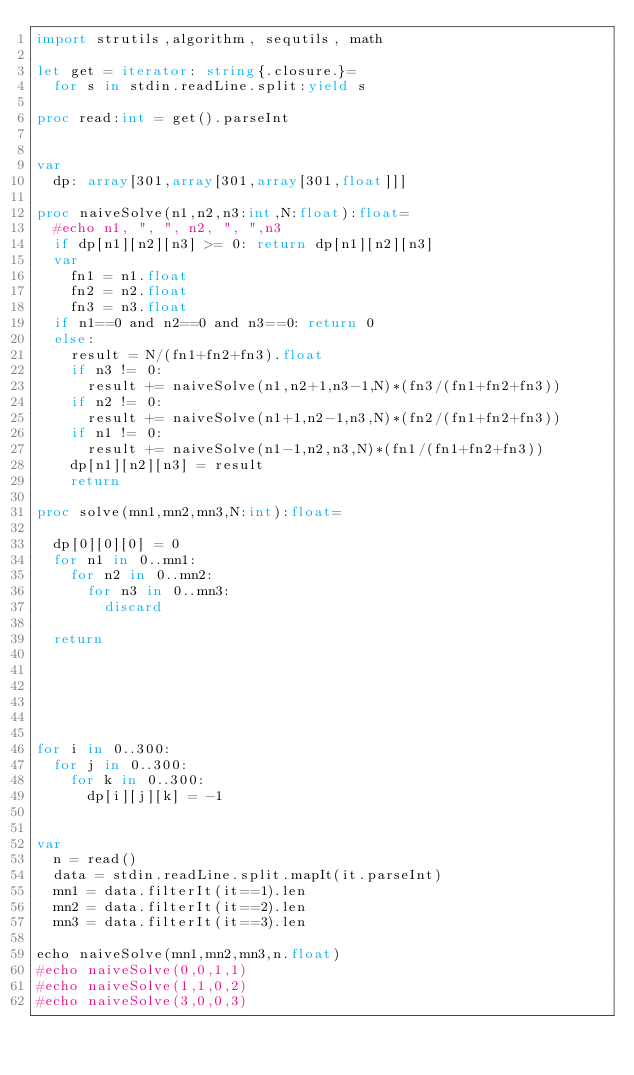<code> <loc_0><loc_0><loc_500><loc_500><_Nim_>import strutils,algorithm, sequtils, math

let get = iterator: string{.closure.}=
  for s in stdin.readLine.split:yield s

proc read:int = get().parseInt


var
  dp: array[301,array[301,array[301,float]]]

proc naiveSolve(n1,n2,n3:int,N:float):float=
  #echo n1, ", ", n2, ", ",n3
  if dp[n1][n2][n3] >= 0: return dp[n1][n2][n3]
  var
    fn1 = n1.float
    fn2 = n2.float
    fn3 = n3.float
  if n1==0 and n2==0 and n3==0: return 0
  else:
    result = N/(fn1+fn2+fn3).float
    if n3 != 0:
      result += naiveSolve(n1,n2+1,n3-1,N)*(fn3/(fn1+fn2+fn3))
    if n2 != 0:
      result += naiveSolve(n1+1,n2-1,n3,N)*(fn2/(fn1+fn2+fn3))
    if n1 != 0:
      result += naiveSolve(n1-1,n2,n3,N)*(fn1/(fn1+fn2+fn3))
    dp[n1][n2][n3] = result
    return

proc solve(mn1,mn2,mn3,N:int):float=
  
  dp[0][0][0] = 0
  for n1 in 0..mn1:
    for n2 in 0..mn2:
      for n3 in 0..mn3:
        discard

  return






for i in 0..300:
  for j in 0..300:
    for k in 0..300:
      dp[i][j][k] = -1


var
  n = read()
  data = stdin.readLine.split.mapIt(it.parseInt)
  mn1 = data.filterIt(it==1).len
  mn2 = data.filterIt(it==2).len
  mn3 = data.filterIt(it==3).len

echo naiveSolve(mn1,mn2,mn3,n.float) 
#echo naiveSolve(0,0,1,1)
#echo naiveSolve(1,1,0,2)
#echo naiveSolve(3,0,0,3)
</code> 